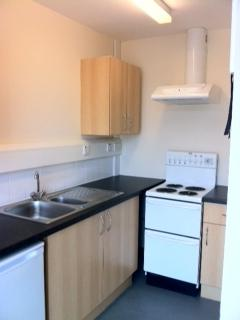Question: what color is the countertop?
Choices:
A. Brown.
B. White.
C. Black.
D. Silver.
Answer with the letter. Answer: C Question: what room is this?
Choices:
A. Kitchen.
B. Living room.
C. Dining room.
D. Bedroom.
Answer with the letter. Answer: A Question: what is the sink made of?
Choices:
A. Stainless steel.
B. Metal.
C. Porcelain.
D. Glass.
Answer with the letter. Answer: B Question: where was the picture taken?
Choices:
A. Under a bridge.
B. By a mountain.
C. In a kitchen.
D. By a river.
Answer with the letter. Answer: C 